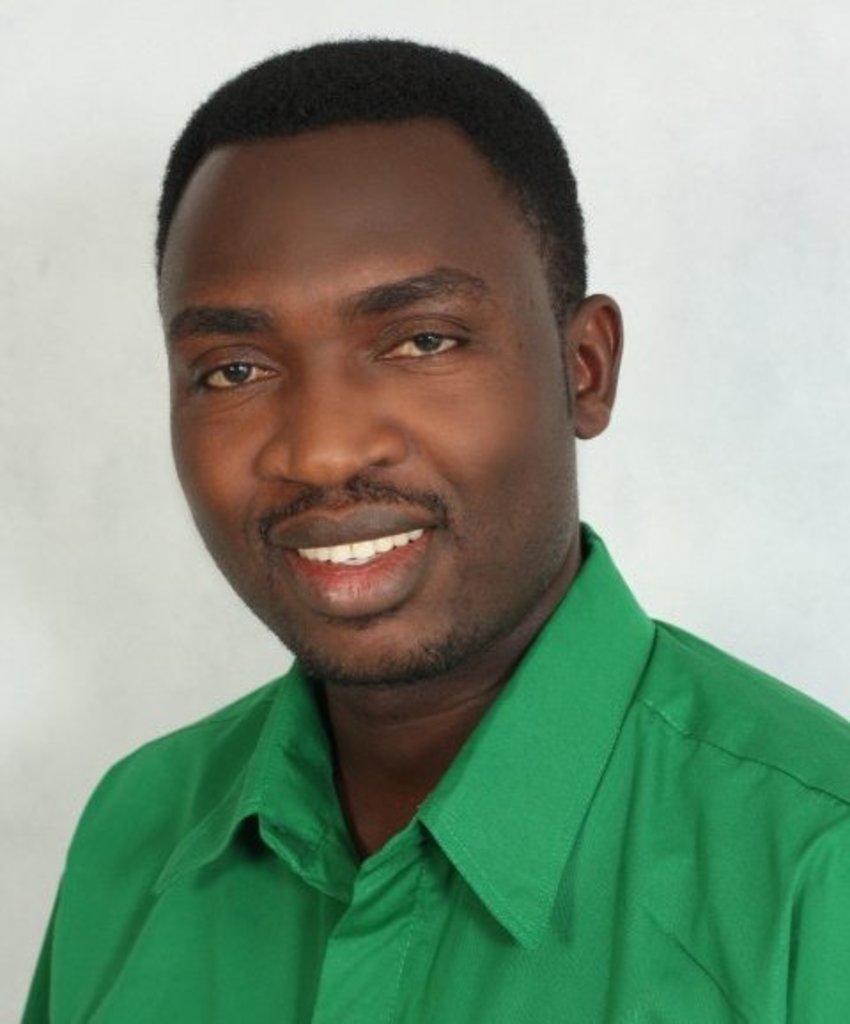Please provide a concise description of this image. There is a man wore green color shirt and smiling. 